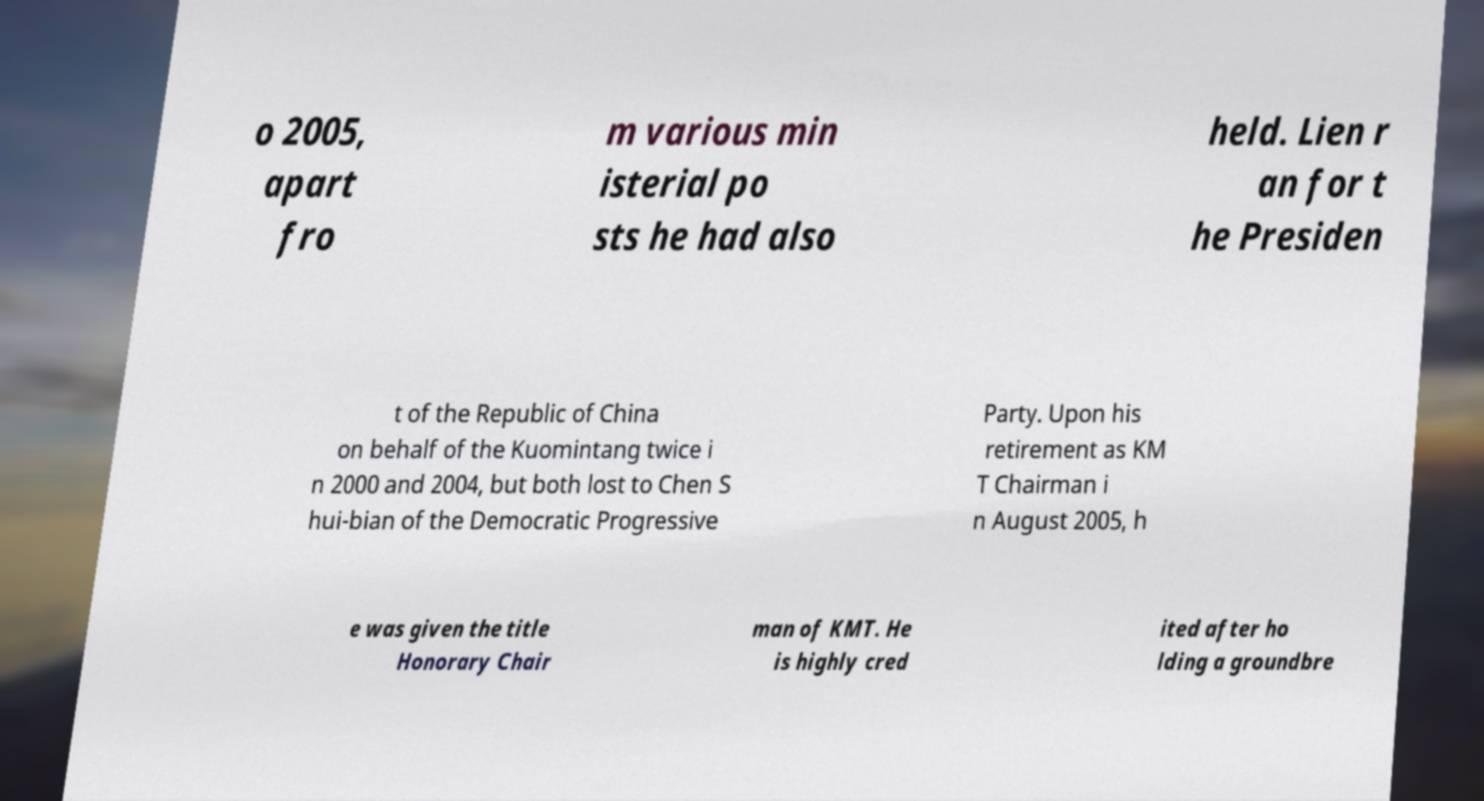I need the written content from this picture converted into text. Can you do that? o 2005, apart fro m various min isterial po sts he had also held. Lien r an for t he Presiden t of the Republic of China on behalf of the Kuomintang twice i n 2000 and 2004, but both lost to Chen S hui-bian of the Democratic Progressive Party. Upon his retirement as KM T Chairman i n August 2005, h e was given the title Honorary Chair man of KMT. He is highly cred ited after ho lding a groundbre 